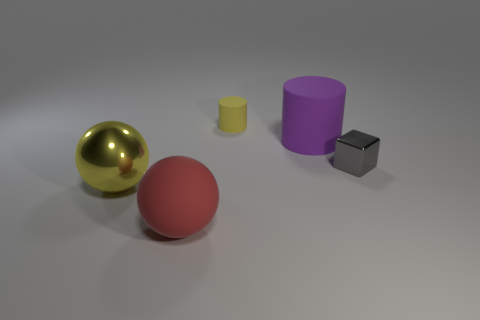Is there anything else that has the same material as the tiny cylinder?
Your answer should be compact. Yes. How many things are yellow matte things or large objects that are in front of the small metallic block?
Make the answer very short. 3. Is the size of the yellow object that is behind the gray shiny thing the same as the tiny gray cube?
Keep it short and to the point. Yes. What number of other things are the same shape as the small rubber object?
Ensure brevity in your answer.  1. What number of red things are either metallic cylinders or large rubber balls?
Make the answer very short. 1. Do the large sphere behind the large red object and the rubber ball have the same color?
Offer a terse response. No. What shape is the object that is made of the same material as the tiny cube?
Give a very brief answer. Sphere. What is the color of the object that is behind the matte sphere and left of the small rubber cylinder?
Offer a very short reply. Yellow. What size is the yellow object behind the metallic object left of the gray shiny thing?
Ensure brevity in your answer.  Small. Are there any other tiny cubes that have the same color as the small shiny block?
Your answer should be very brief. No. 